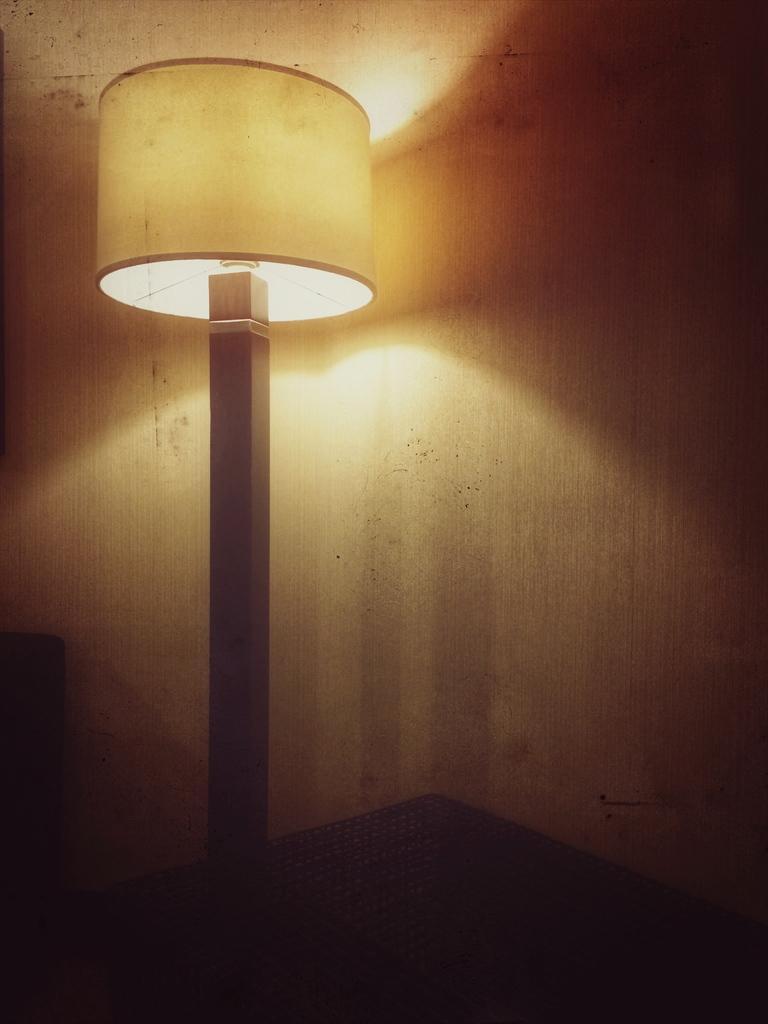Can you describe this image briefly? This picture seems to be clicked inside the room. In the center we can see a lamp and we can see some other objects. In the background there is an object which seems to be the wall. 